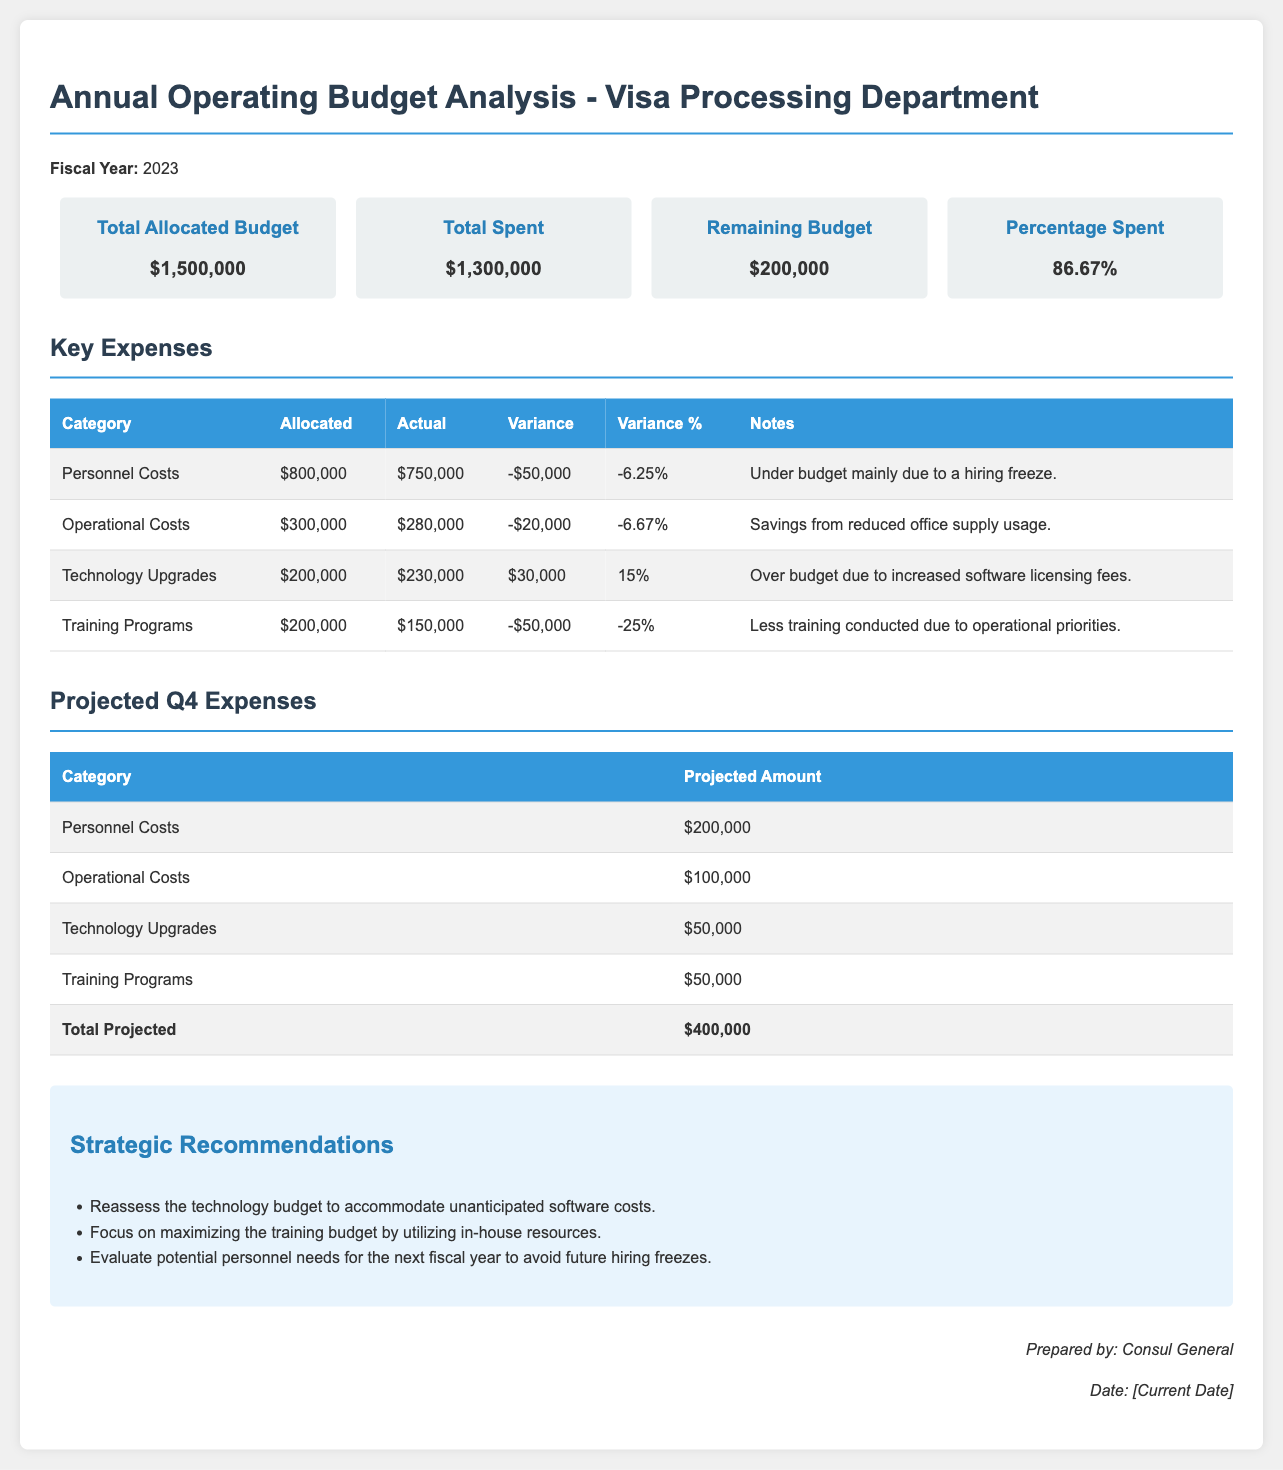What is the fiscal year of the report? The fiscal year of the report is explicitly stated at the beginning of the document.
Answer: 2023 What is the total allocated budget? The total allocated budget is provided in the budget overview section.
Answer: $1,500,000 What are the total spent expenses? The total spent expenses are mentioned in the budget overview section.
Answer: $1,300,000 What is the remaining budget? The remaining budget is indicated in the budget overview section.
Answer: $200,000 What is the variance for Technology Upgrades? The variance for Technology Upgrades is calculated from the allocated and actual amounts in the key expenses section.
Answer: $30,000 What percentage of the budget has been spent? The percentage spent is included in the budget overview section.
Answer: 86.67% What is the projected amount for Operational Costs in Q4? The projected amount can be found in the projected Q4 expenses table.
Answer: $100,000 What strategic recommendation is made regarding the training budget? The strategic recommendations section suggests actions related to the training budget.
Answer: Utilize in-house resources What caused the personnel costs to be under budget? The notes in the key expenses section explain the reason for the variance in personnel costs.
Answer: Hiring freeze What is the total projected amount for Q4 expenses? The total projected amount is summarized at the bottom of the projected Q4 expenses table.
Answer: $400,000 